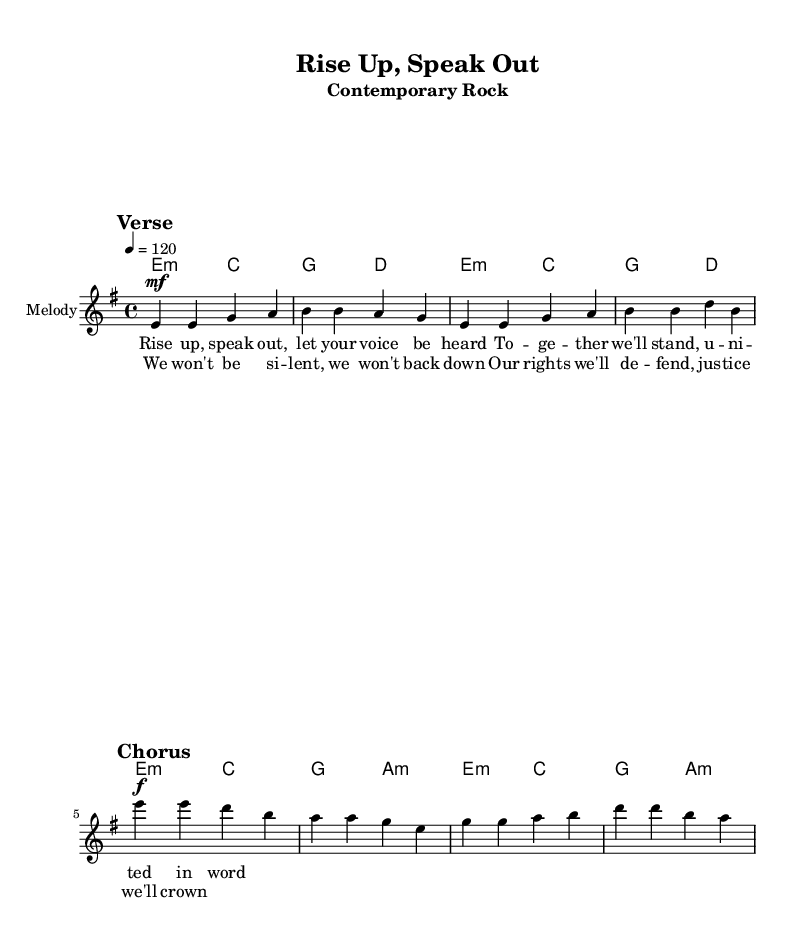What is the key signature of this music? The key signature is E minor, which has one sharp (F#), indicated at the beginning of the staff.
Answer: E minor What is the time signature of this music? The time signature is 4/4, shown at the beginning of the score, indicating four beats per measure.
Answer: 4/4 What is the tempo marking for this piece? The tempo marking indicates a speed of 120 beats per minute, noted in the tempo indication at the start of the score.
Answer: 120 How many measures are in the verse section? The verse section contains four measures, as observed by counting the groups of notes before transitioning to the chorus.
Answer: 4 What dynamic marking is used for the chorus? The dynamic marking used for the chorus is forte, indicated by the "f" notation before this section of the music.
Answer: forte What is the relationship between the verse and chorus in terms of thematics? Thematically, both the verse and chorus advocate for unity and justice, as expressed in the lyrics that emphasize speaking out and defending rights against injustice.
Answer: Unity and justice In what style is this song composed? The song is composed in a contemporary rock style, characterized by its use of guitar chords and a strong rhythmic drive typical of the genre.
Answer: Contemporary rock 